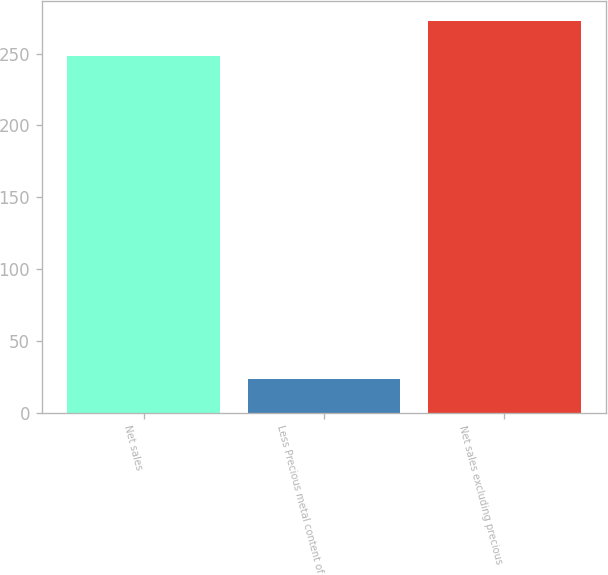<chart> <loc_0><loc_0><loc_500><loc_500><bar_chart><fcel>Net sales<fcel>Less Precious metal content of<fcel>Net sales excluding precious<nl><fcel>248.1<fcel>23.8<fcel>272.91<nl></chart> 